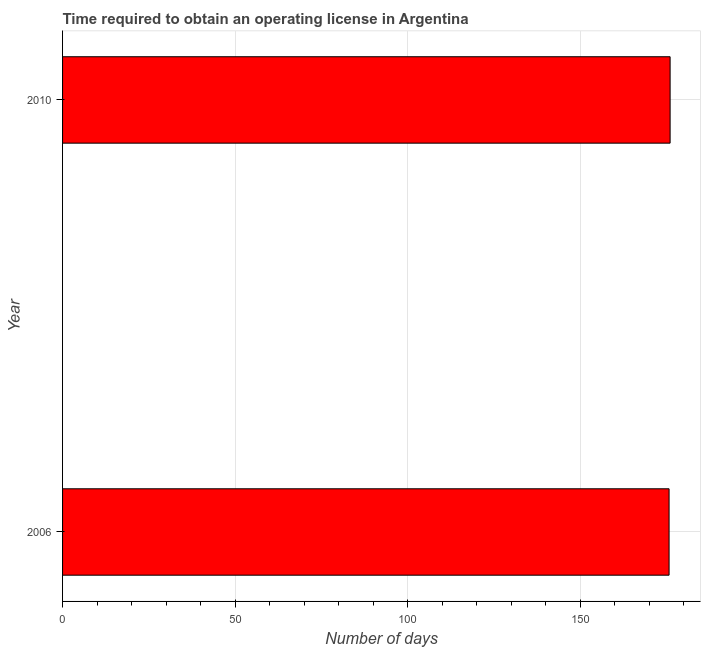Does the graph contain any zero values?
Offer a terse response. No. What is the title of the graph?
Keep it short and to the point. Time required to obtain an operating license in Argentina. What is the label or title of the X-axis?
Make the answer very short. Number of days. What is the number of days to obtain operating license in 2010?
Your response must be concise. 176.1. Across all years, what is the maximum number of days to obtain operating license?
Offer a terse response. 176.1. Across all years, what is the minimum number of days to obtain operating license?
Provide a short and direct response. 175.8. In which year was the number of days to obtain operating license maximum?
Make the answer very short. 2010. What is the sum of the number of days to obtain operating license?
Offer a terse response. 351.9. What is the difference between the number of days to obtain operating license in 2006 and 2010?
Make the answer very short. -0.3. What is the average number of days to obtain operating license per year?
Provide a succinct answer. 175.95. What is the median number of days to obtain operating license?
Ensure brevity in your answer.  175.95. In how many years, is the number of days to obtain operating license greater than 140 days?
Your answer should be very brief. 2. Do a majority of the years between 2006 and 2010 (inclusive) have number of days to obtain operating license greater than 30 days?
Keep it short and to the point. Yes. What is the ratio of the number of days to obtain operating license in 2006 to that in 2010?
Ensure brevity in your answer.  1. Is the number of days to obtain operating license in 2006 less than that in 2010?
Your response must be concise. Yes. How many years are there in the graph?
Your response must be concise. 2. What is the difference between two consecutive major ticks on the X-axis?
Provide a succinct answer. 50. Are the values on the major ticks of X-axis written in scientific E-notation?
Your answer should be compact. No. What is the Number of days in 2006?
Offer a very short reply. 175.8. What is the Number of days in 2010?
Your answer should be very brief. 176.1. 